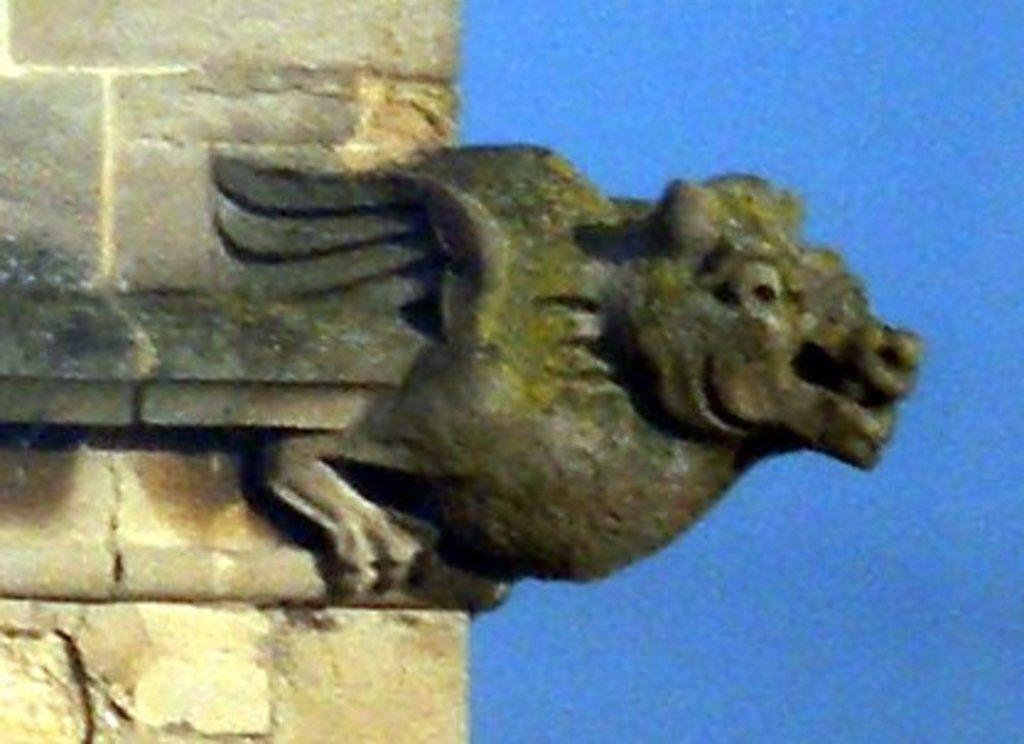What is the main structure in the image? There is a pillar in the image. What colors are used for the pillar? The pillar is cream and black in color. What is attached to the pillar? There is a sculpture of an animal attached to the pillar. What can be seen in the background of the image? The sky is visible in the background of the image. What color is the sky in the image? The sky is blue in color. What type of cactus can be seen growing on the pillar in the image? There is no cactus present on the pillar in the image; it features a sculpture of an animal. What is the tendency of the drum in the image? There is no drum present in the image. 